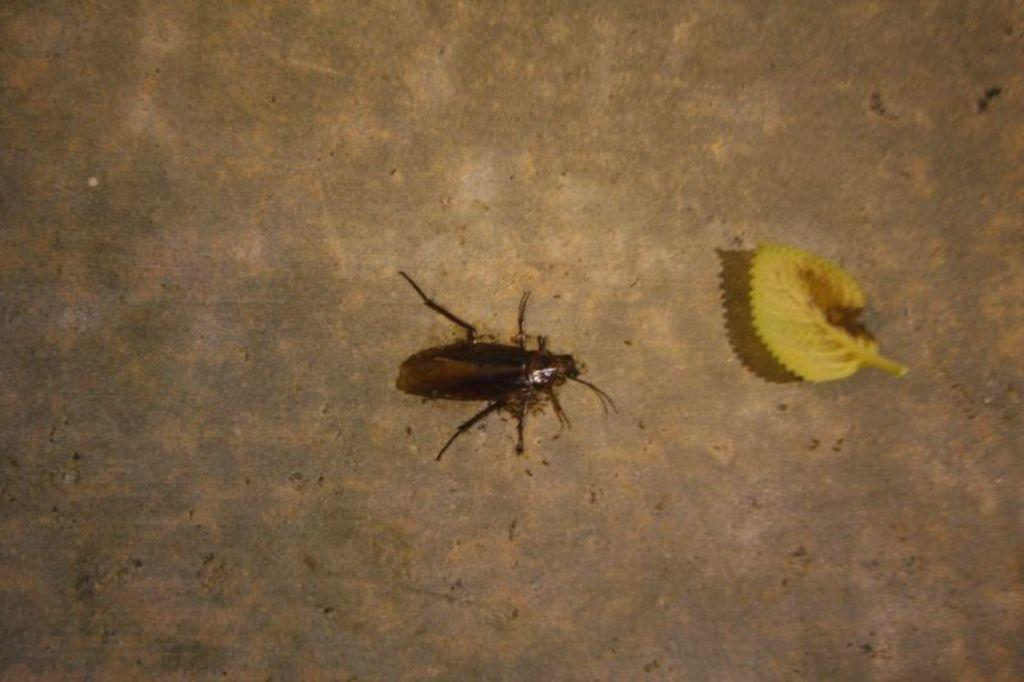What type of creature is present in the image? There is an insect in the image. What colors can be seen on the insect? The insect has brown and black colors. What other object is present in the image? There is a yellow color leaf in the image. What is the background or surface on which the insect and leaf are placed? The insect and leaf are on a brown surface. What type of mint plant can be seen growing near the insect in the image? There is no mint plant present in the image; it only features an insect, a yellow leaf, and a brown surface. 